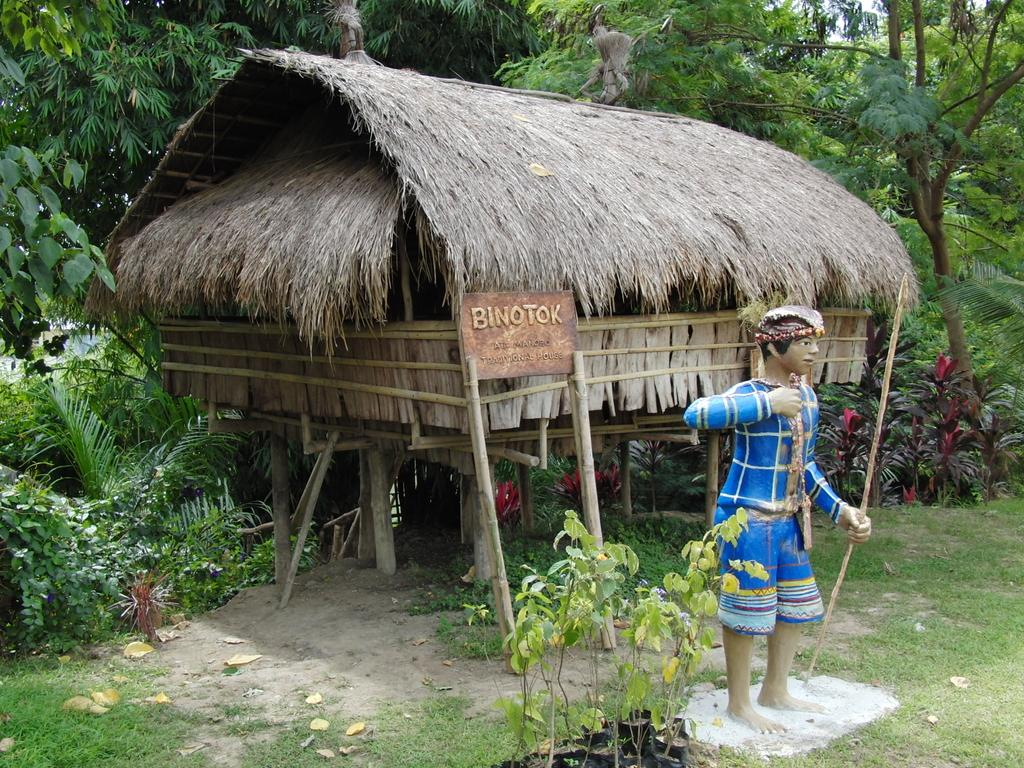What type of vegetation can be seen in the image? There are many trees and plants in the image. What is the ground made of in the image? There is a grassy land in the image. What man-made structure is present in the image? There is a sculpture and a hut in the image. What type of string is used to create the sculpture in the image? There is no mention of string being used to create the sculpture in the image. The sculpture's construction method is not specified in the provided facts. 